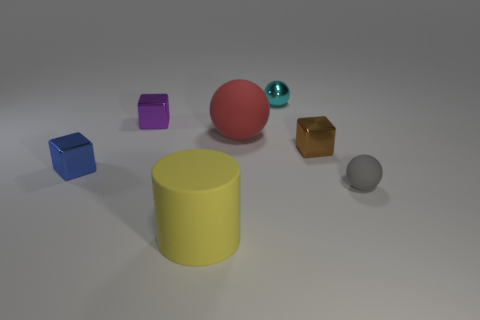Is the number of tiny brown shiny cubes greater than the number of tiny things?
Your answer should be compact. No. What material is the brown thing?
Your answer should be very brief. Metal. How many other things are there of the same material as the gray sphere?
Make the answer very short. 2. How many small purple things are there?
Your answer should be compact. 1. There is another tiny thing that is the same shape as the gray rubber thing; what is it made of?
Provide a short and direct response. Metal. Are the ball that is on the left side of the tiny cyan sphere and the cyan ball made of the same material?
Ensure brevity in your answer.  No. Are there more brown metallic objects that are in front of the cyan thing than blue blocks that are to the left of the brown block?
Offer a terse response. No. What is the size of the gray matte sphere?
Offer a terse response. Small. What shape is the cyan thing that is made of the same material as the brown object?
Provide a succinct answer. Sphere. There is a big object that is on the right side of the yellow rubber object; does it have the same shape as the large yellow rubber thing?
Your answer should be compact. No. 